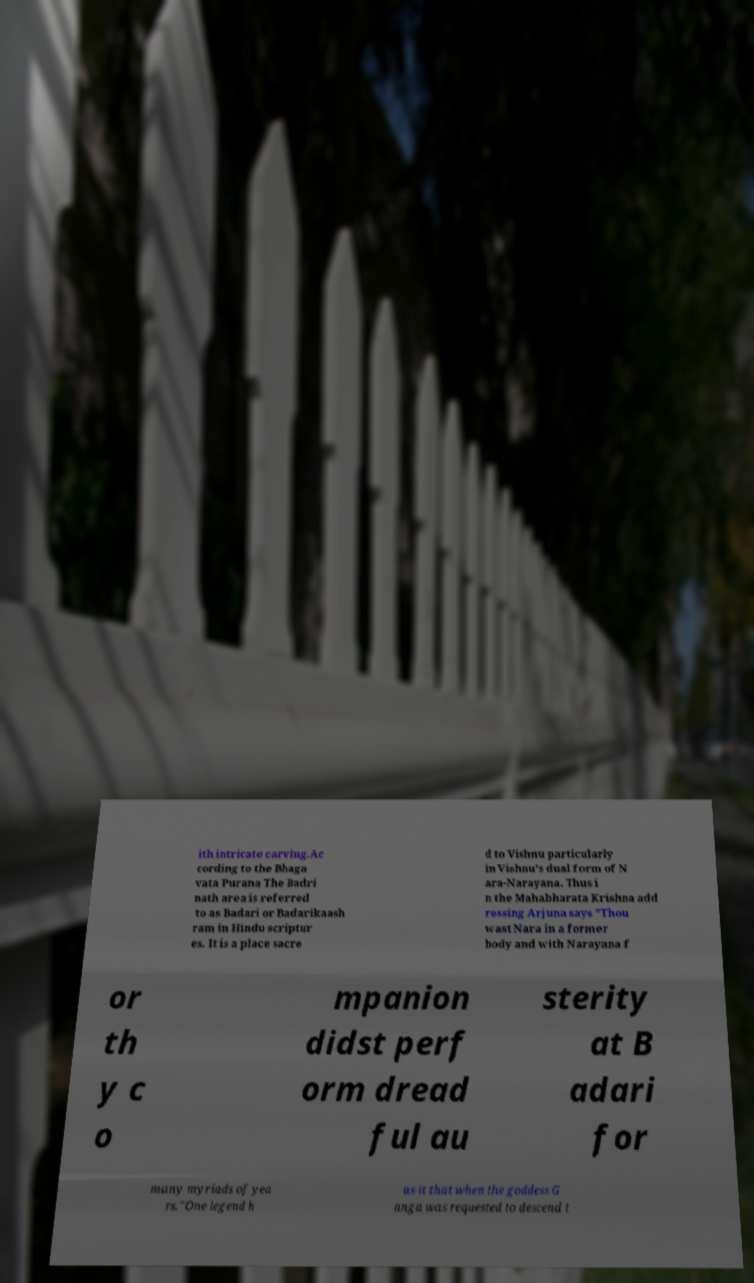For documentation purposes, I need the text within this image transcribed. Could you provide that? ith intricate carving.Ac cording to the Bhaga vata Purana The Badri nath area is referred to as Badari or Badarikaash ram in Hindu scriptur es. It is a place sacre d to Vishnu particularly in Vishnu's dual form of N ara-Narayana. Thus i n the Mahabharata Krishna add ressing Arjuna says "Thou wast Nara in a former body and with Narayana f or th y c o mpanion didst perf orm dread ful au sterity at B adari for many myriads of yea rs."One legend h as it that when the goddess G anga was requested to descend t 